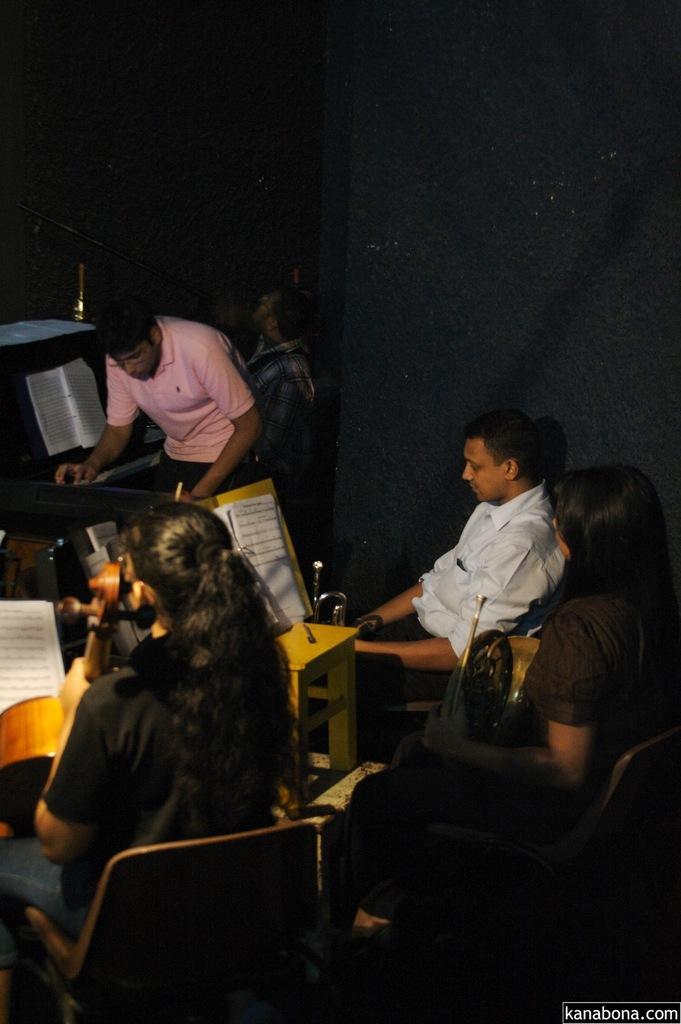Can you describe this image briefly? Here we can see a group of people and some of them are sitting on chairs they are practicing their musical instruments and some of them are standing and practicing then musical instrument 